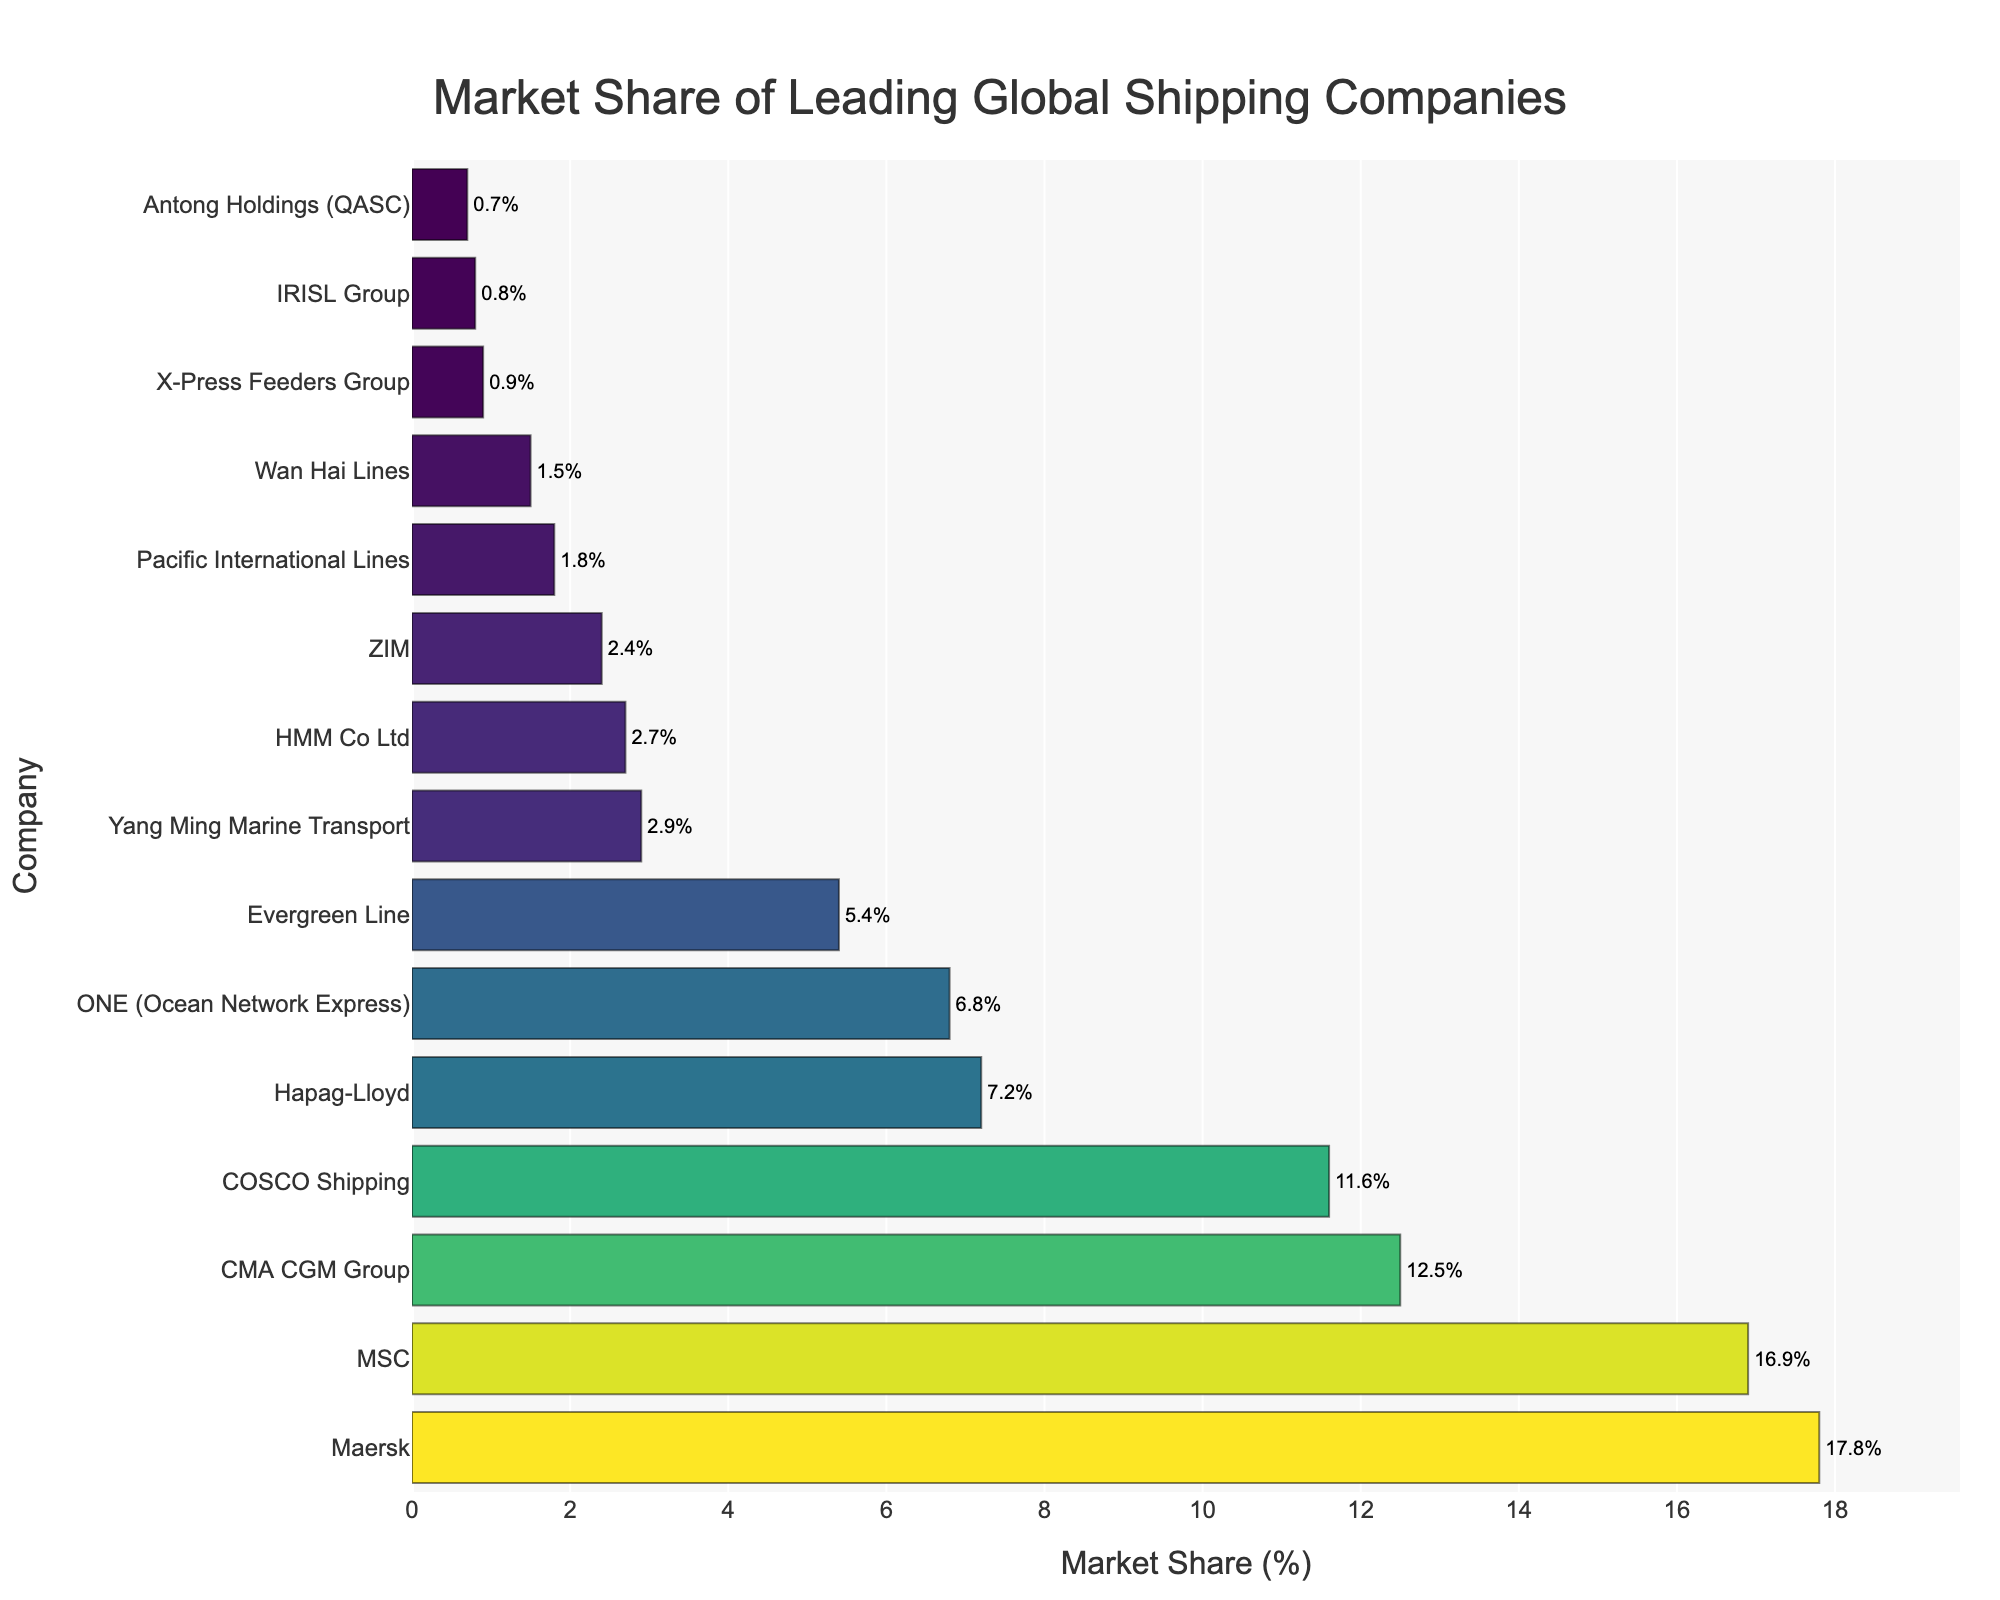What company has the largest market share? By comparing the bars in the chart, the bar representing Maersk is the longest, indicating it has the largest market share.
Answer: Maersk Compare the market share of Maersk and MSC. Which one is larger and by how much? Maersk's market share is 17.8% while MSC's market share is 16.9%. The difference is 17.8% - 16.9% = 0.9%.
Answer: Maersk, by 0.9% What is the combined market share of the top three companies? The top three companies are Maersk (17.8%), MSC (16.9%), and CMA CGM Group (12.5%). Their combined market share is 17.8% + 16.9% + 12.5% = 47.2%.
Answer: 47.2% Which companies have a market share greater than 10%? By observing the bars representing market shares, we see that Maersk (17.8%), MSC (16.9%), CMA CGM Group (12.5%), and COSCO Shipping (11.6%) have market shares greater than 10%.
Answer: Maersk, MSC, CMA CGM Group, COSCO Shipping Is ONE (Ocean Network Express) larger in market share than Hapag-Lloyd? ONE (Ocean Network Express) has a market share of 6.8%, while Hapag-Lloyd has 7.2%. Hapag-Lloyd's share is larger.
Answer: No What is the average market share of the bottom five companies? The bottom five companies are ZIM (2.4%), Pacific International Lines (1.8%), Wan Hai Lines (1.5%), X-Press Feeders Group (0.9%), and IRISL Group (0.8%). Their average market share is (2.4% + 1.8% + 1.5% + 0.9% + 0.8%) / 5 = 1.48%.
Answer: 1.48% Between Evergreen Line and Yang Ming Marine Transport, which company has a higher market share and by what percent? Evergreen Line has a market share of 5.4%, while Yang Ming Marine Transport has 2.9%. The difference is 5.4% - 2.9% = 2.5%.
Answer: Evergreen Line, by 2.5% Are there any companies with a market share less than 1%? If yes, name them. By identifying bars shorter than the 1% mark, the companies are X-Press Feeders Group (0.9%), IRISL Group (0.8%), and Antong Holdings (QASC) (0.7%).
Answer: X-Press Feeders Group, IRISL Group, Antong Holdings (QASC) What is the total market share of companies with a market share less than 5%? The companies are Yang Ming Marine Transport (2.9%), HMM Co Ltd (2.7%), ZIM (2.4%), Pacific International Lines (1.8%), Wan Hai Lines (1.5%), X-Press Feeders Group (0.9%), IRISL Group (0.8%), and Antong Holdings (QASC) (0.7%). Their total market share is 2.9% + 2.7% + 2.4% + 1.8% + 1.5% + 0.9% + 0.8% + 0.7% = 13.7%.
Answer: 13.7% Which company is represented by the bar with the darkest color? The darkest color in the Viridis color scale is used for the highest market share value. This bar represents Maersk, with a market share of 17.8%.
Answer: Maersk 